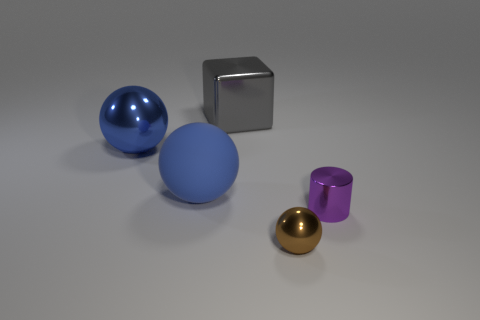Subtract all brown cylinders. Subtract all yellow balls. How many cylinders are left? 1 Add 3 small blue rubber things. How many objects exist? 8 Subtract all blocks. How many objects are left? 4 Subtract all tiny brown metal spheres. Subtract all big gray objects. How many objects are left? 3 Add 2 gray objects. How many gray objects are left? 3 Add 1 gray spheres. How many gray spheres exist? 1 Subtract 0 cyan cylinders. How many objects are left? 5 